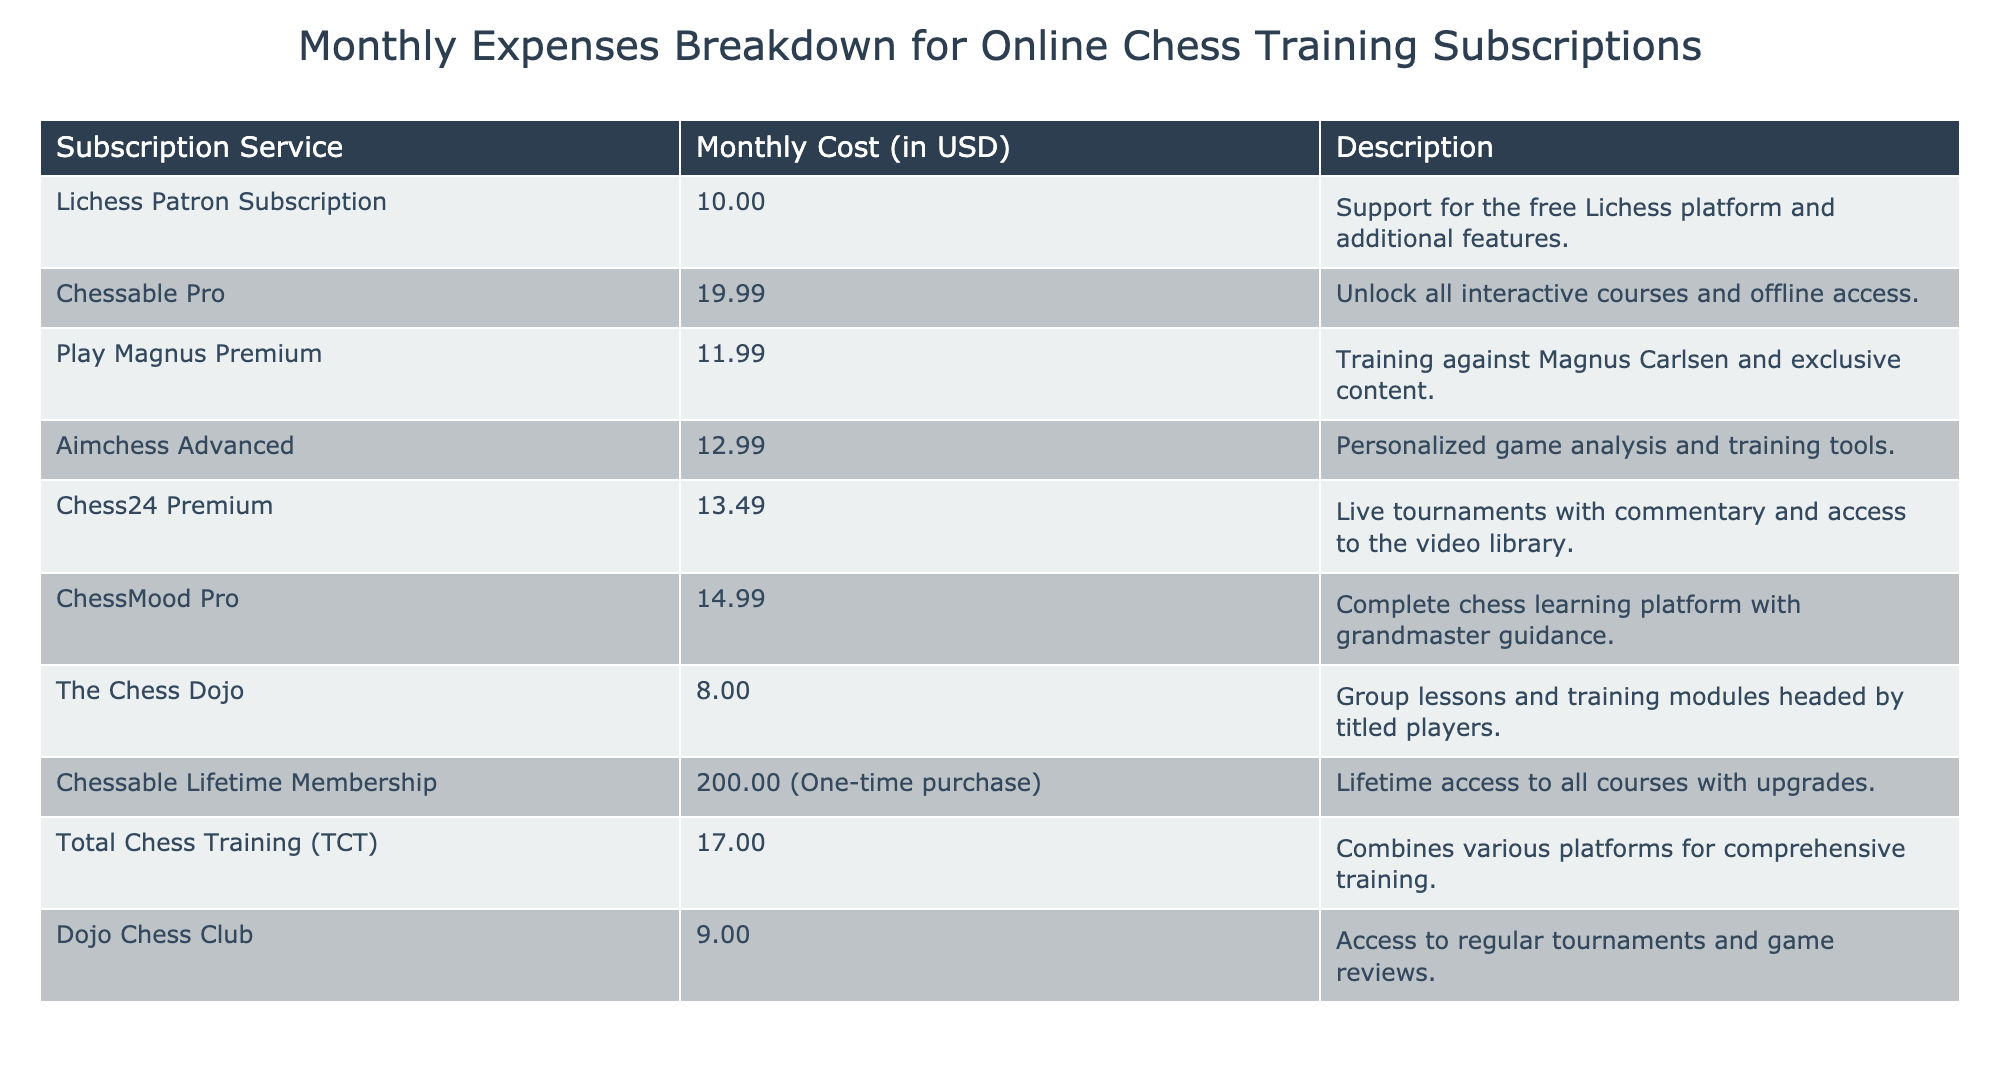What is the monthly cost of the Chessable Pro subscription? The table lists the monthly cost of each subscription service. For Chessable Pro, it specifically states a cost of 19.99 USD in the "Monthly Cost (in USD)" column.
Answer: 19.99 USD What is the total monthly cost of all subscriptions listed? To calculate the total monthly cost, we need to sum the monthly costs of all subscriptions. Adding the values gives: 10.00 + 19.99 + 11.99 + 12.99 + 13.49 + 14.99 + 8.00 + 17.00 + 9.00 = 117.45. However, the Chessable Lifetime Membership is a one-time purchase, so we omit it for the monthly total.
Answer: 117.45 USD Is the Dojo Chess Club subscription cheaper than Aimchess Advanced? The cost of Dojo Chess Club is 9.00 USD, while Aimchess Advanced costs 12.99 USD. Since 9.00 is less than 12.99, the statement is true.
Answer: Yes What is the average monthly cost of the subscriptions that provide personalized training tools? The subscriptions that mention personalized training tools are Aimchess Advanced (12.99) and ChessMood Pro (14.99). To find the average, we sum these costs: 12.99 + 14.99 = 27.98, and then divide by the number of subscriptions, which is 2. Thus, the average is 27.98 / 2 = 13.99.
Answer: 13.99 USD Which subscription has the highest cost and what is that cost? By examining the "Monthly Cost (in USD)" column, the highest cost listed is for the Chessable Lifetime Membership, which is a one-time purchase at 200.00 USD, not a monthly cost. Therefore, among monthly subscriptions, Chessable Pro is the highest at 19.99 USD.
Answer: 19.99 USD Does Lichess Patron Subscription offer additional features? The description of the Lichess Patron Subscription clearly states that it supports the free Lichess platform and provides additional features. Therefore, the answer is true.
Answer: Yes How much more expensive is ChessMood Pro compared to Play Magnus Premium? ChessMood Pro costs 14.99 USD and Play Magnus Premium costs 11.99 USD. To find the difference, we subtract the latter from the former: 14.99 - 11.99 = 3.00. So, ChessMood Pro is 3.00 USD more expensive.
Answer: 3.00 USD What is the total cost for the three most affordable subscriptions? The three lowest monthly costs are for The Chess Dojo (8.00), Dojo Chess Club (9.00), and Lichess Patron Subscription (10.00). Summing these we get: 8.00 + 9.00 + 10.00 = 27.00.
Answer: 27.00 USD 